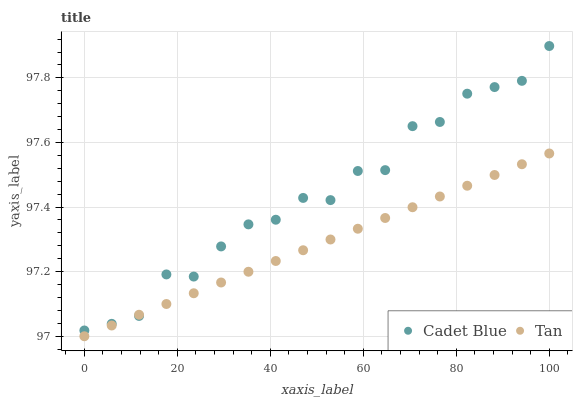Does Tan have the minimum area under the curve?
Answer yes or no. Yes. Does Cadet Blue have the maximum area under the curve?
Answer yes or no. Yes. Does Cadet Blue have the minimum area under the curve?
Answer yes or no. No. Is Tan the smoothest?
Answer yes or no. Yes. Is Cadet Blue the roughest?
Answer yes or no. Yes. Is Cadet Blue the smoothest?
Answer yes or no. No. Does Tan have the lowest value?
Answer yes or no. Yes. Does Cadet Blue have the lowest value?
Answer yes or no. No. Does Cadet Blue have the highest value?
Answer yes or no. Yes. Does Cadet Blue intersect Tan?
Answer yes or no. Yes. Is Cadet Blue less than Tan?
Answer yes or no. No. Is Cadet Blue greater than Tan?
Answer yes or no. No. 